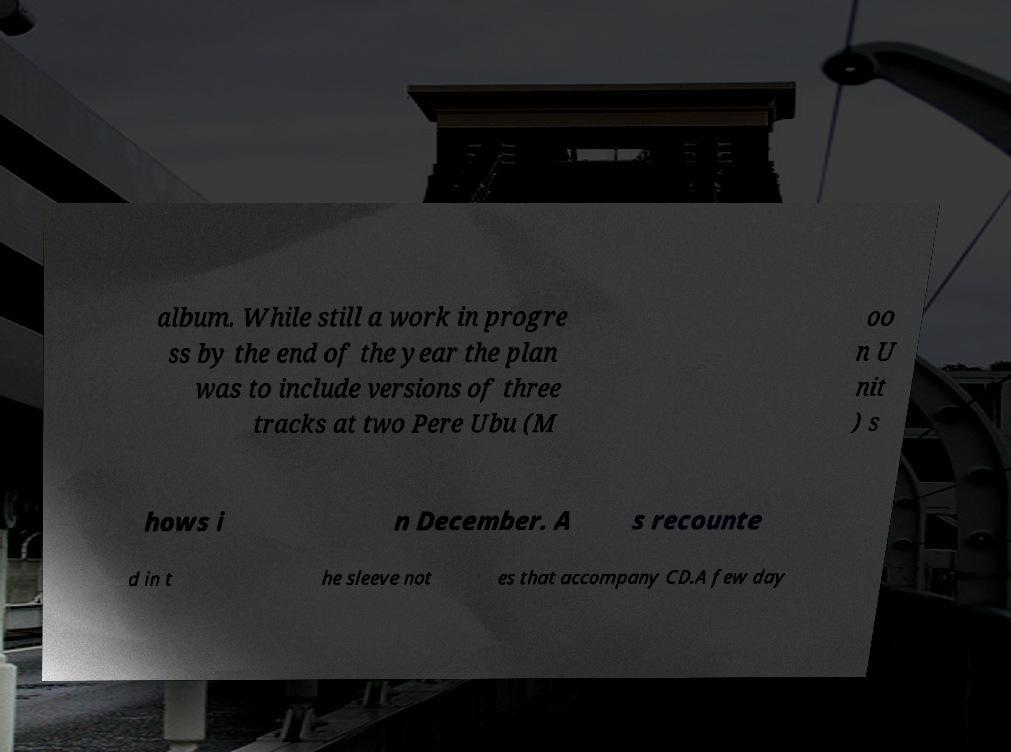Can you accurately transcribe the text from the provided image for me? album. While still a work in progre ss by the end of the year the plan was to include versions of three tracks at two Pere Ubu (M oo n U nit ) s hows i n December. A s recounte d in t he sleeve not es that accompany CD.A few day 